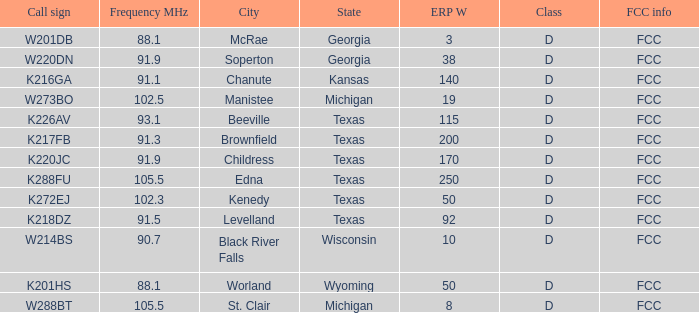Would you mind parsing the complete table? {'header': ['Call sign', 'Frequency MHz', 'City', 'State', 'ERP W', 'Class', 'FCC info'], 'rows': [['W201DB', '88.1', 'McRae', 'Georgia', '3', 'D', 'FCC'], ['W220DN', '91.9', 'Soperton', 'Georgia', '38', 'D', 'FCC'], ['K216GA', '91.1', 'Chanute', 'Kansas', '140', 'D', 'FCC'], ['W273BO', '102.5', 'Manistee', 'Michigan', '19', 'D', 'FCC'], ['K226AV', '93.1', 'Beeville', 'Texas', '115', 'D', 'FCC'], ['K217FB', '91.3', 'Brownfield', 'Texas', '200', 'D', 'FCC'], ['K220JC', '91.9', 'Childress', 'Texas', '170', 'D', 'FCC'], ['K288FU', '105.5', 'Edna', 'Texas', '250', 'D', 'FCC'], ['K272EJ', '102.3', 'Kenedy', 'Texas', '50', 'D', 'FCC'], ['K218DZ', '91.5', 'Levelland', 'Texas', '92', 'D', 'FCC'], ['W214BS', '90.7', 'Black River Falls', 'Wisconsin', '10', 'D', 'FCC'], ['K201HS', '88.1', 'Worland', 'Wyoming', '50', 'D', 'FCC'], ['W288BT', '105.5', 'St. Clair', 'Michigan', '8', 'D', 'FCC']]} What is City of License, when ERP W is greater than 3, and when Call Sign is K218DZ? Levelland, Texas. 